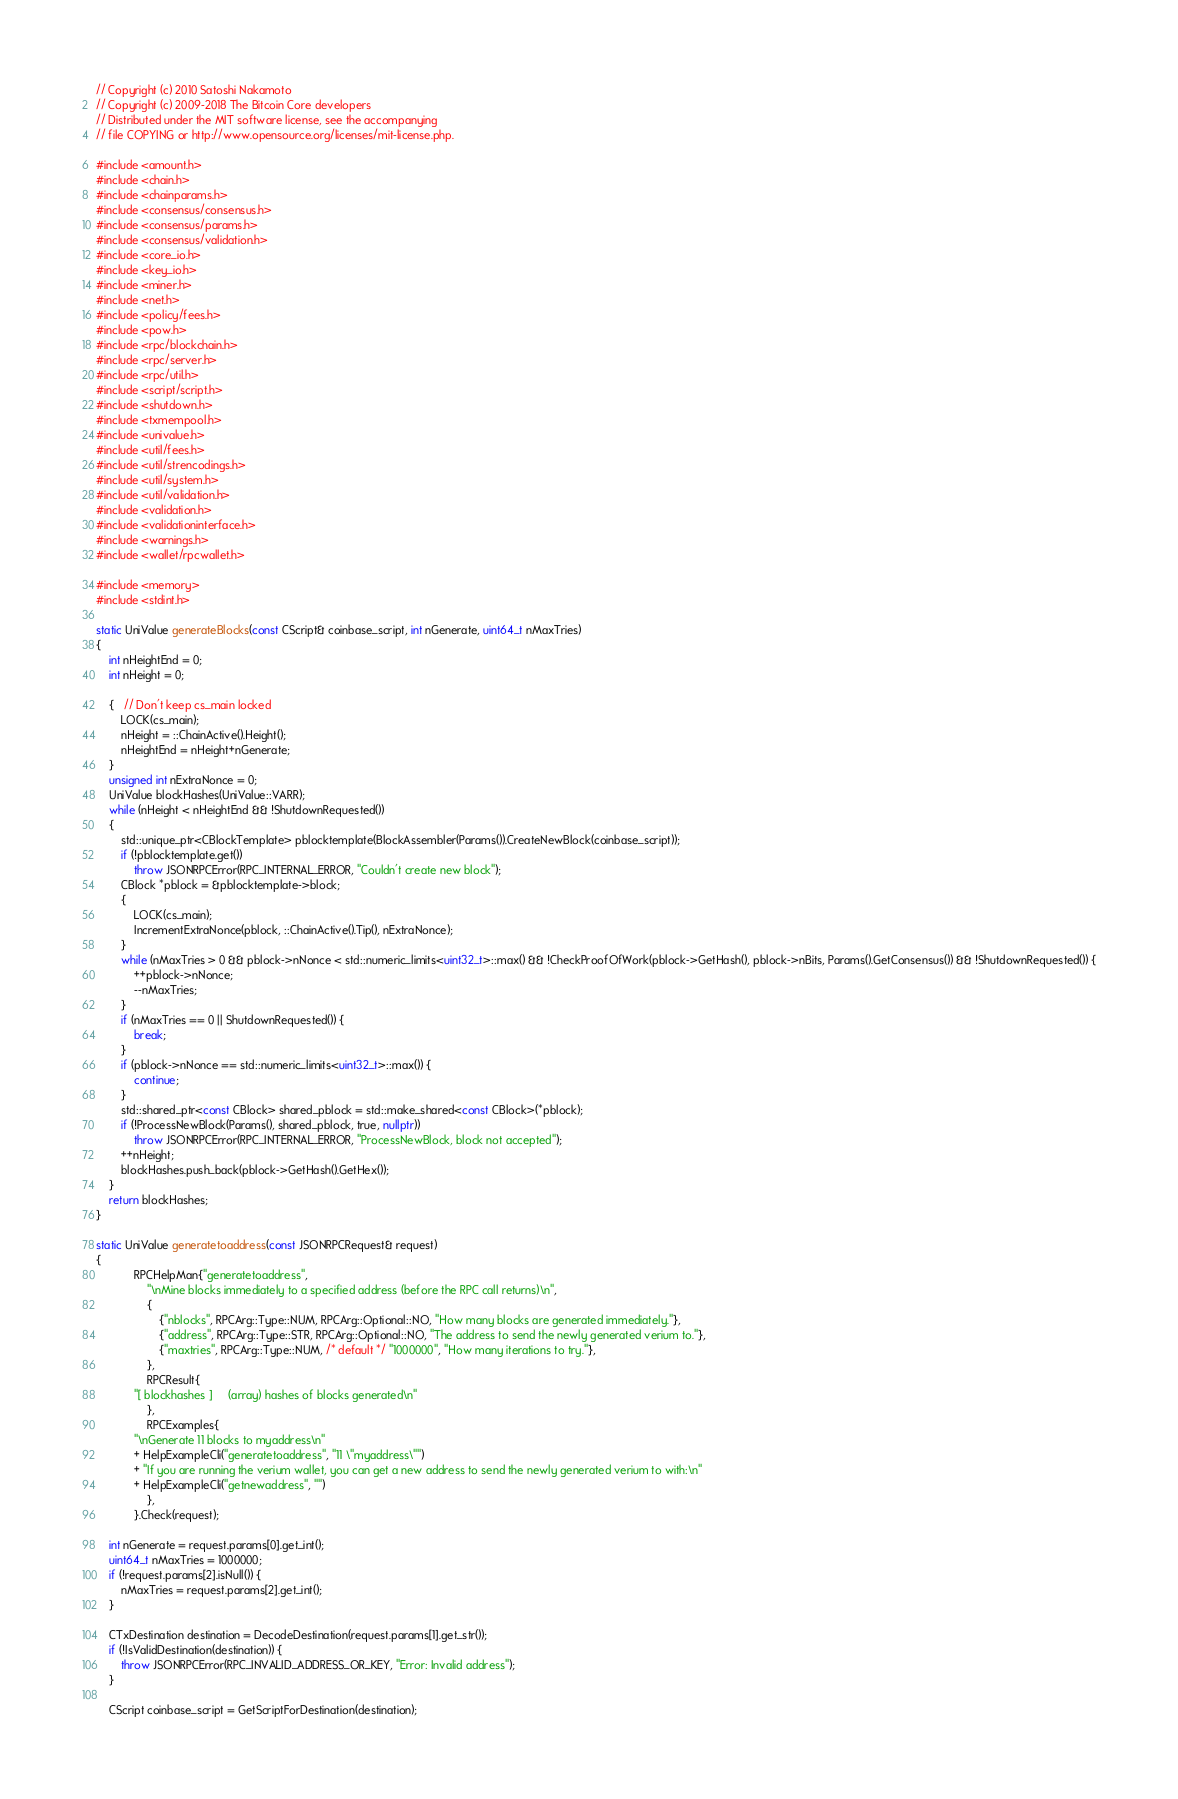<code> <loc_0><loc_0><loc_500><loc_500><_C++_>// Copyright (c) 2010 Satoshi Nakamoto
// Copyright (c) 2009-2018 The Bitcoin Core developers
// Distributed under the MIT software license, see the accompanying
// file COPYING or http://www.opensource.org/licenses/mit-license.php.

#include <amount.h>
#include <chain.h>
#include <chainparams.h>
#include <consensus/consensus.h>
#include <consensus/params.h>
#include <consensus/validation.h>
#include <core_io.h>
#include <key_io.h>
#include <miner.h>
#include <net.h>
#include <policy/fees.h>
#include <pow.h>
#include <rpc/blockchain.h>
#include <rpc/server.h>
#include <rpc/util.h>
#include <script/script.h>
#include <shutdown.h>
#include <txmempool.h>
#include <univalue.h>
#include <util/fees.h>
#include <util/strencodings.h>
#include <util/system.h>
#include <util/validation.h>
#include <validation.h>
#include <validationinterface.h>
#include <warnings.h>
#include <wallet/rpcwallet.h>

#include <memory>
#include <stdint.h>

static UniValue generateBlocks(const CScript& coinbase_script, int nGenerate, uint64_t nMaxTries)
{
    int nHeightEnd = 0;
    int nHeight = 0;

    {   // Don't keep cs_main locked
        LOCK(cs_main);
        nHeight = ::ChainActive().Height();
        nHeightEnd = nHeight+nGenerate;
    }
    unsigned int nExtraNonce = 0;
    UniValue blockHashes(UniValue::VARR);
    while (nHeight < nHeightEnd && !ShutdownRequested())
    {
        std::unique_ptr<CBlockTemplate> pblocktemplate(BlockAssembler(Params()).CreateNewBlock(coinbase_script));
        if (!pblocktemplate.get())
            throw JSONRPCError(RPC_INTERNAL_ERROR, "Couldn't create new block");
        CBlock *pblock = &pblocktemplate->block;
        {
            LOCK(cs_main);
            IncrementExtraNonce(pblock, ::ChainActive().Tip(), nExtraNonce);
        }
        while (nMaxTries > 0 && pblock->nNonce < std::numeric_limits<uint32_t>::max() && !CheckProofOfWork(pblock->GetHash(), pblock->nBits, Params().GetConsensus()) && !ShutdownRequested()) {
            ++pblock->nNonce;
            --nMaxTries;
        }
        if (nMaxTries == 0 || ShutdownRequested()) {
            break;
        }
        if (pblock->nNonce == std::numeric_limits<uint32_t>::max()) {
            continue;
        }
        std::shared_ptr<const CBlock> shared_pblock = std::make_shared<const CBlock>(*pblock);
        if (!ProcessNewBlock(Params(), shared_pblock, true, nullptr))
            throw JSONRPCError(RPC_INTERNAL_ERROR, "ProcessNewBlock, block not accepted");
        ++nHeight;
        blockHashes.push_back(pblock->GetHash().GetHex());
    }
    return blockHashes;
}

static UniValue generatetoaddress(const JSONRPCRequest& request)
{
            RPCHelpMan{"generatetoaddress",
                "\nMine blocks immediately to a specified address (before the RPC call returns)\n",
                {
                    {"nblocks", RPCArg::Type::NUM, RPCArg::Optional::NO, "How many blocks are generated immediately."},
                    {"address", RPCArg::Type::STR, RPCArg::Optional::NO, "The address to send the newly generated verium to."},
                    {"maxtries", RPCArg::Type::NUM, /* default */ "1000000", "How many iterations to try."},
                },
                RPCResult{
            "[ blockhashes ]     (array) hashes of blocks generated\n"
                },
                RPCExamples{
            "\nGenerate 11 blocks to myaddress\n"
            + HelpExampleCli("generatetoaddress", "11 \"myaddress\"")
            + "If you are running the verium wallet, you can get a new address to send the newly generated verium to with:\n"
            + HelpExampleCli("getnewaddress", "")
                },
            }.Check(request);

    int nGenerate = request.params[0].get_int();
    uint64_t nMaxTries = 1000000;
    if (!request.params[2].isNull()) {
        nMaxTries = request.params[2].get_int();
    }

    CTxDestination destination = DecodeDestination(request.params[1].get_str());
    if (!IsValidDestination(destination)) {
        throw JSONRPCError(RPC_INVALID_ADDRESS_OR_KEY, "Error: Invalid address");
    }

    CScript coinbase_script = GetScriptForDestination(destination);
</code> 